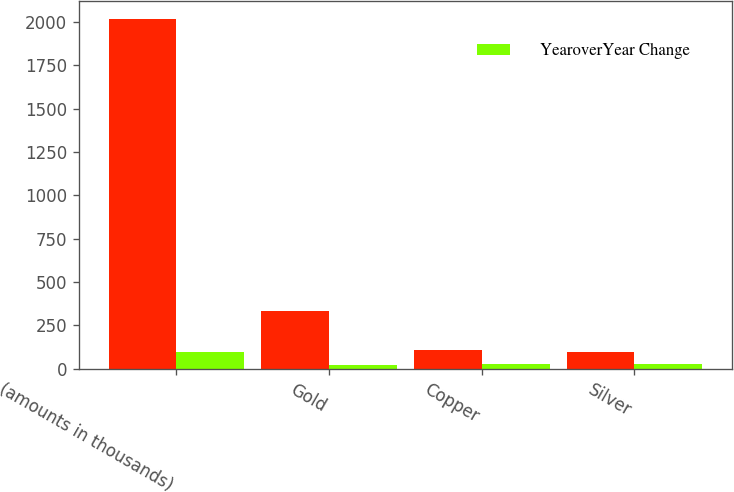Convert chart. <chart><loc_0><loc_0><loc_500><loc_500><stacked_bar_chart><ecel><fcel>(amounts in thousands)<fcel>Gold<fcel>Copper<fcel>Silver<nl><fcel>nan<fcel>2017<fcel>335<fcel>108<fcel>98<nl><fcel>YearoverYear Change<fcel>98<fcel>23<fcel>26<fcel>25<nl></chart> 